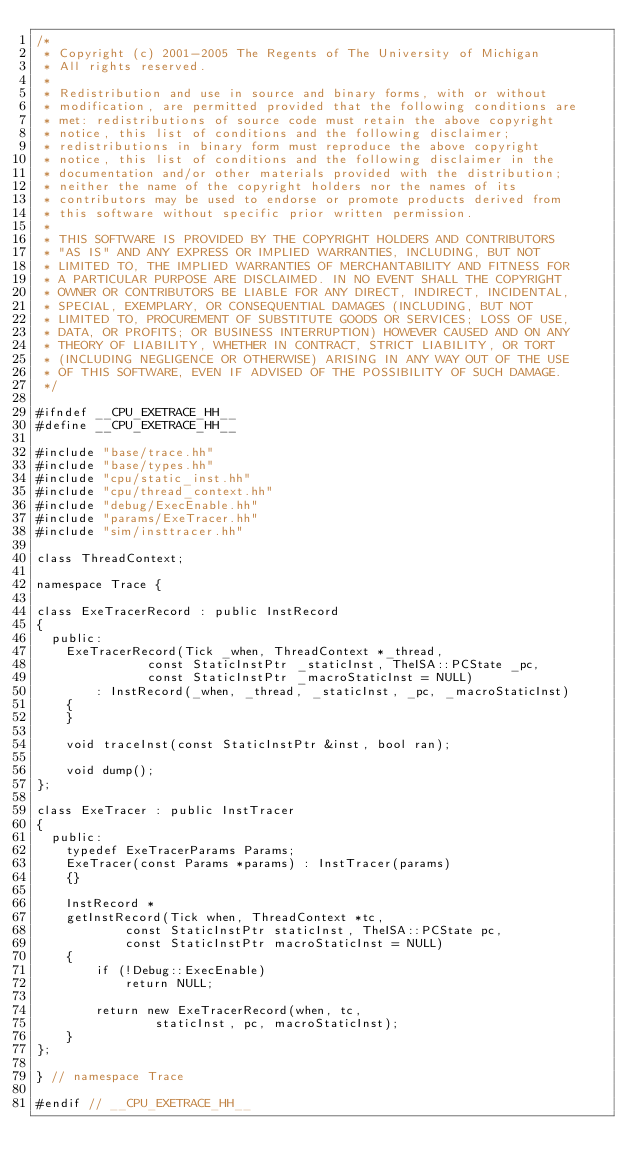<code> <loc_0><loc_0><loc_500><loc_500><_C++_>/*
 * Copyright (c) 2001-2005 The Regents of The University of Michigan
 * All rights reserved.
 *
 * Redistribution and use in source and binary forms, with or without
 * modification, are permitted provided that the following conditions are
 * met: redistributions of source code must retain the above copyright
 * notice, this list of conditions and the following disclaimer;
 * redistributions in binary form must reproduce the above copyright
 * notice, this list of conditions and the following disclaimer in the
 * documentation and/or other materials provided with the distribution;
 * neither the name of the copyright holders nor the names of its
 * contributors may be used to endorse or promote products derived from
 * this software without specific prior written permission.
 *
 * THIS SOFTWARE IS PROVIDED BY THE COPYRIGHT HOLDERS AND CONTRIBUTORS
 * "AS IS" AND ANY EXPRESS OR IMPLIED WARRANTIES, INCLUDING, BUT NOT
 * LIMITED TO, THE IMPLIED WARRANTIES OF MERCHANTABILITY AND FITNESS FOR
 * A PARTICULAR PURPOSE ARE DISCLAIMED. IN NO EVENT SHALL THE COPYRIGHT
 * OWNER OR CONTRIBUTORS BE LIABLE FOR ANY DIRECT, INDIRECT, INCIDENTAL,
 * SPECIAL, EXEMPLARY, OR CONSEQUENTIAL DAMAGES (INCLUDING, BUT NOT
 * LIMITED TO, PROCUREMENT OF SUBSTITUTE GOODS OR SERVICES; LOSS OF USE,
 * DATA, OR PROFITS; OR BUSINESS INTERRUPTION) HOWEVER CAUSED AND ON ANY
 * THEORY OF LIABILITY, WHETHER IN CONTRACT, STRICT LIABILITY, OR TORT
 * (INCLUDING NEGLIGENCE OR OTHERWISE) ARISING IN ANY WAY OUT OF THE USE
 * OF THIS SOFTWARE, EVEN IF ADVISED OF THE POSSIBILITY OF SUCH DAMAGE.
 */

#ifndef __CPU_EXETRACE_HH__
#define __CPU_EXETRACE_HH__

#include "base/trace.hh"
#include "base/types.hh"
#include "cpu/static_inst.hh"
#include "cpu/thread_context.hh"
#include "debug/ExecEnable.hh"
#include "params/ExeTracer.hh"
#include "sim/insttracer.hh"

class ThreadContext;

namespace Trace {

class ExeTracerRecord : public InstRecord
{
  public:
    ExeTracerRecord(Tick _when, ThreadContext *_thread,
               const StaticInstPtr _staticInst, TheISA::PCState _pc,
               const StaticInstPtr _macroStaticInst = NULL)
        : InstRecord(_when, _thread, _staticInst, _pc, _macroStaticInst)
    {
    }

    void traceInst(const StaticInstPtr &inst, bool ran);

    void dump();
};

class ExeTracer : public InstTracer
{
  public:
    typedef ExeTracerParams Params;
    ExeTracer(const Params *params) : InstTracer(params)
    {}

    InstRecord *
    getInstRecord(Tick when, ThreadContext *tc,
            const StaticInstPtr staticInst, TheISA::PCState pc,
            const StaticInstPtr macroStaticInst = NULL)
    {
        if (!Debug::ExecEnable)
            return NULL;

        return new ExeTracerRecord(when, tc,
                staticInst, pc, macroStaticInst);
    }
};

} // namespace Trace

#endif // __CPU_EXETRACE_HH__
</code> 